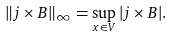Convert formula to latex. <formula><loc_0><loc_0><loc_500><loc_500>\| { j } \times { B } \| _ { \infty } = \sup _ { { x } \in V } | { j } \times { B } | .</formula> 